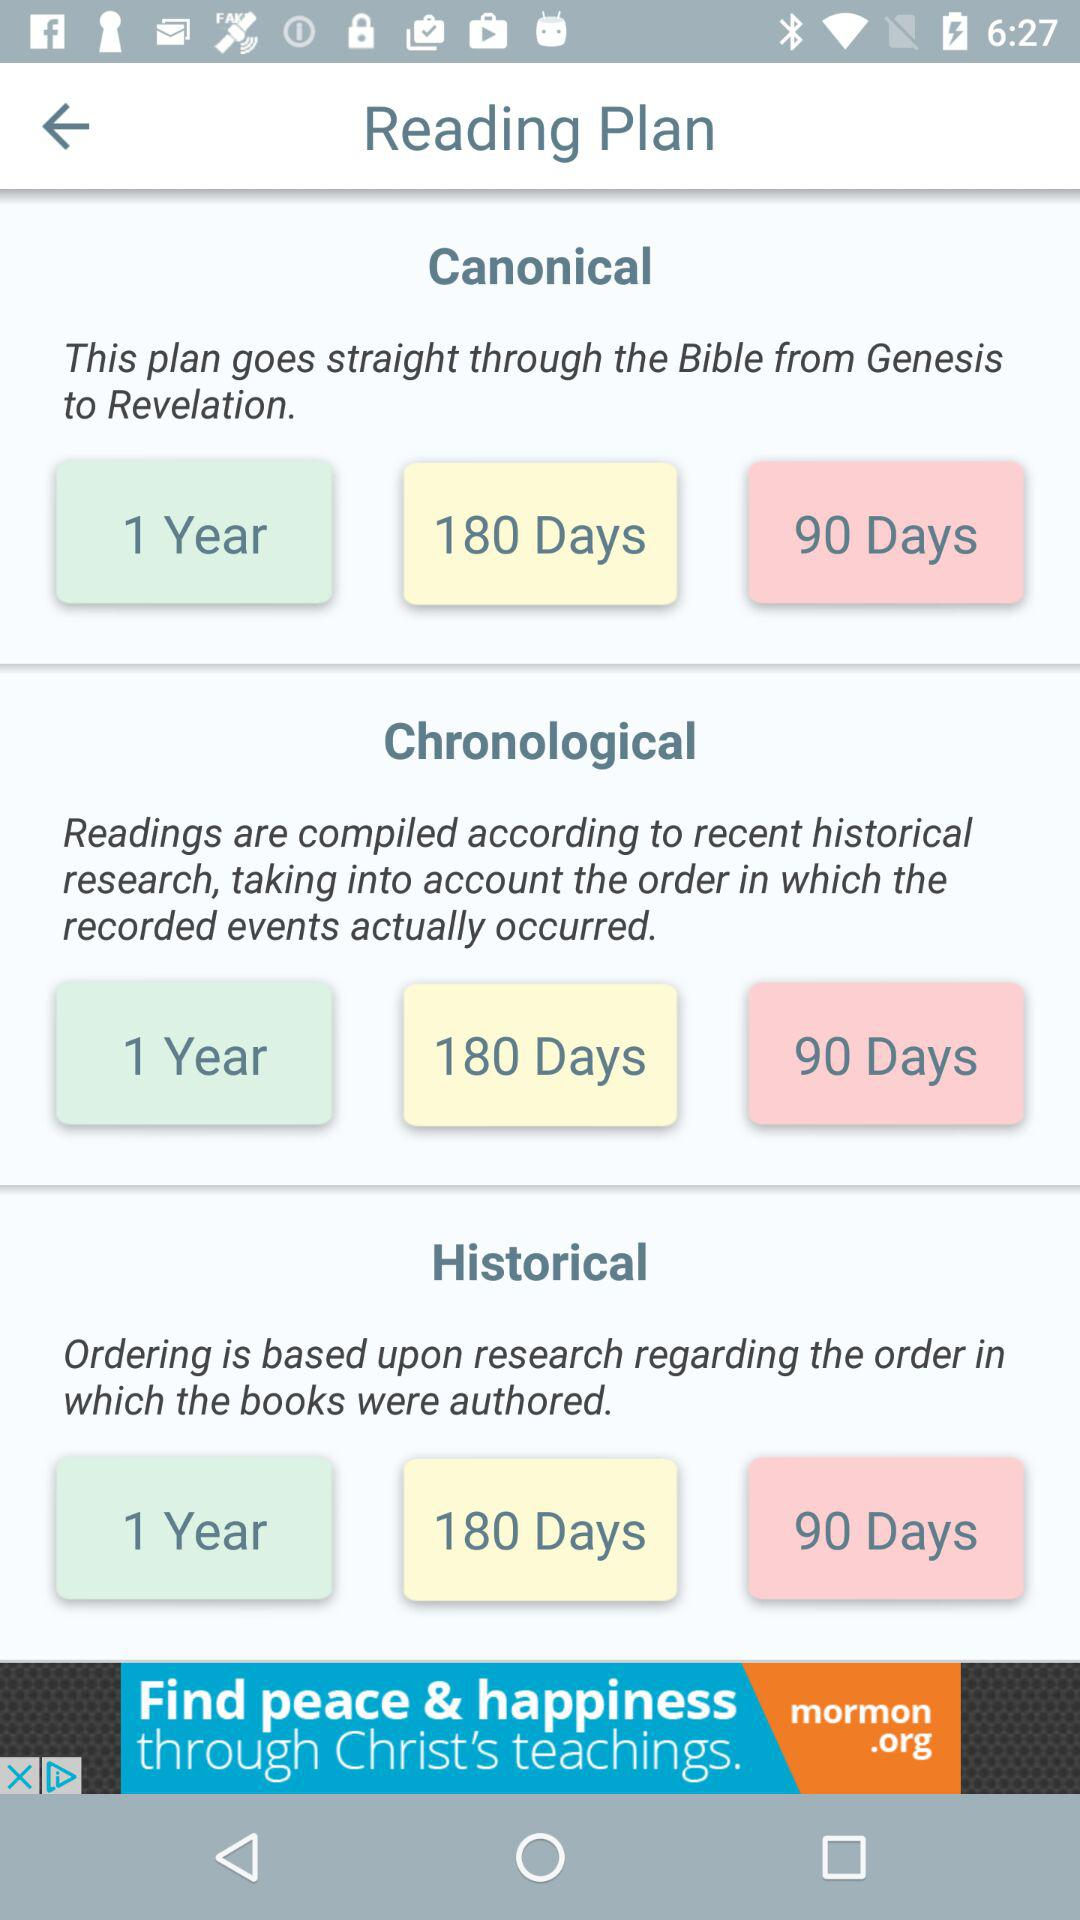How many reading plans are there?
Answer the question using a single word or phrase. 3 